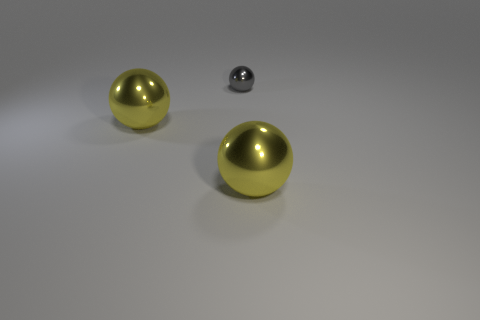How many yellow spheres must be subtracted to get 1 yellow spheres? 1 Add 2 small metal balls. How many objects exist? 5 Add 3 tiny gray shiny things. How many tiny gray shiny things are left? 4 Add 1 large red rubber spheres. How many large red rubber spheres exist? 1 Subtract 0 cyan cylinders. How many objects are left? 3 Subtract all tiny brown metal cylinders. Subtract all tiny gray balls. How many objects are left? 2 